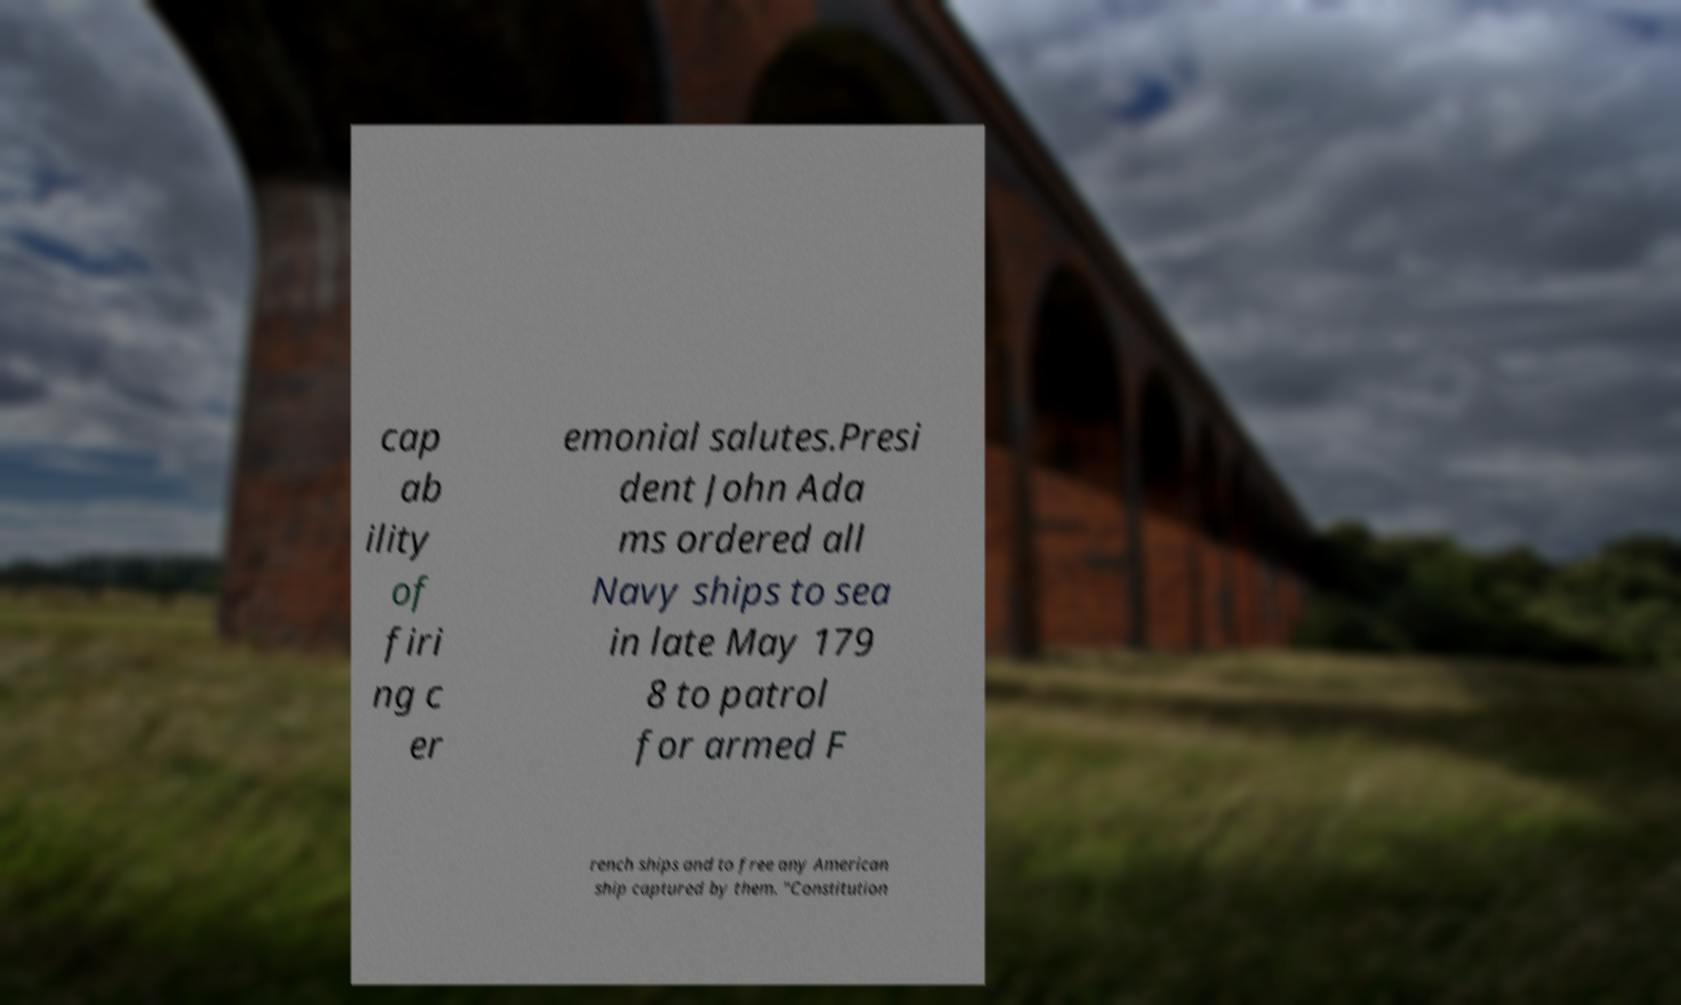I need the written content from this picture converted into text. Can you do that? cap ab ility of firi ng c er emonial salutes.Presi dent John Ada ms ordered all Navy ships to sea in late May 179 8 to patrol for armed F rench ships and to free any American ship captured by them. "Constitution 